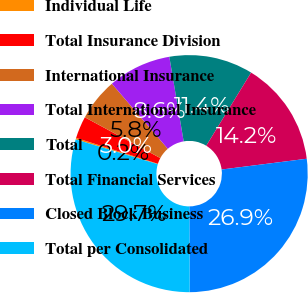<chart> <loc_0><loc_0><loc_500><loc_500><pie_chart><fcel>Individual Life<fcel>Total Insurance Division<fcel>International Insurance<fcel>Total International Insurance<fcel>Total<fcel>Total Financial Services<fcel>Closed Block Business<fcel>Total per Consolidated<nl><fcel>0.21%<fcel>3.01%<fcel>5.82%<fcel>8.62%<fcel>11.43%<fcel>14.24%<fcel>26.93%<fcel>29.74%<nl></chart> 